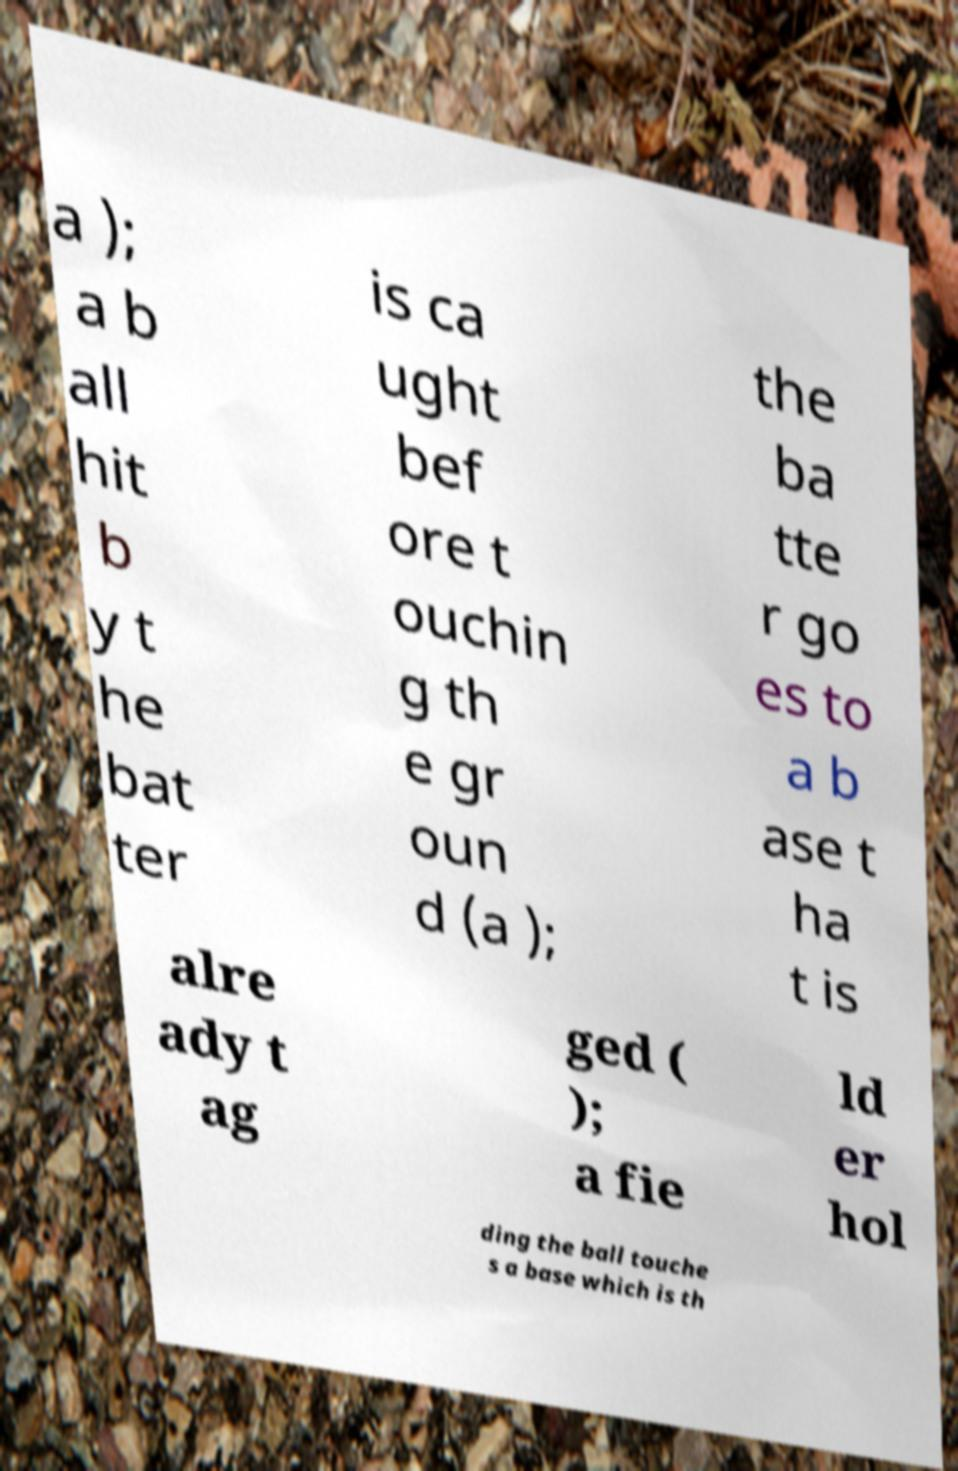Can you read and provide the text displayed in the image?This photo seems to have some interesting text. Can you extract and type it out for me? a ); a b all hit b y t he bat ter is ca ught bef ore t ouchin g th e gr oun d (a ); the ba tte r go es to a b ase t ha t is alre ady t ag ged ( ); a fie ld er hol ding the ball touche s a base which is th 